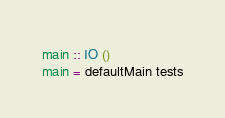<code> <loc_0><loc_0><loc_500><loc_500><_Haskell_>main :: IO ()
main = defaultMain tests
</code> 